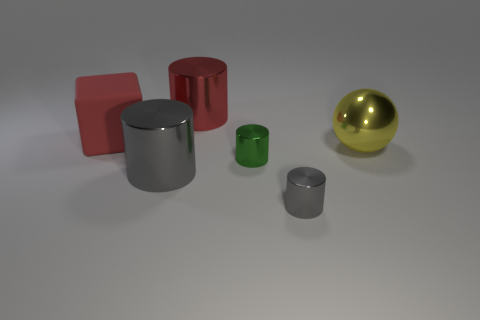Is the number of big gray metal cylinders that are on the left side of the rubber cube greater than the number of big yellow objects? The number of big gray metal cylinders on the left side of the rubber cube is equal to the number of big yellow objects; there is one of each. 